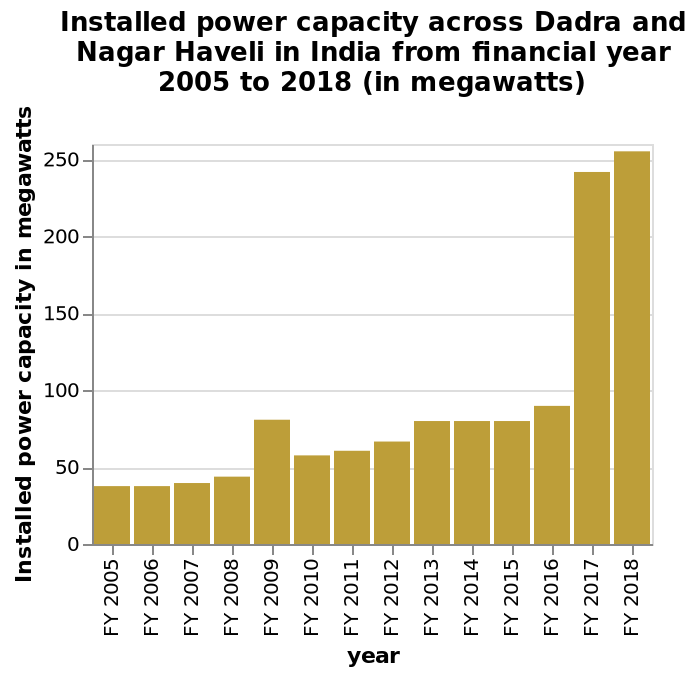<image>
Has there been any significant change in capacity between 2005 and 2016? Yes, there has been a fairly steady increase in capacity during that period. What is the maximum installed power capacity recorded in Dadra and Nagar Haveli? The maximum installed power capacity recorded in Dadra and Nagar Haveli is 250 megawatts. What does the x-axis represent in the bar plot? The x-axis represents the financial years from 2005 to 2018. 